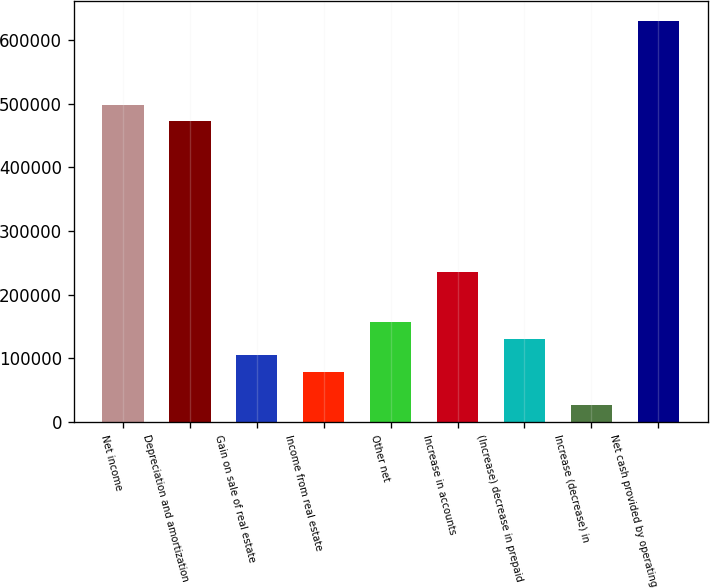<chart> <loc_0><loc_0><loc_500><loc_500><bar_chart><fcel>Net income<fcel>Depreciation and amortization<fcel>Gain on sale of real estate<fcel>Income from real estate<fcel>Other net<fcel>Increase in accounts<fcel>(Increase) decrease in prepaid<fcel>Increase (decrease) in<fcel>Net cash provided by operating<nl><fcel>498233<fcel>472022<fcel>105078<fcel>78867.9<fcel>157499<fcel>236130<fcel>131288<fcel>26447.3<fcel>629284<nl></chart> 